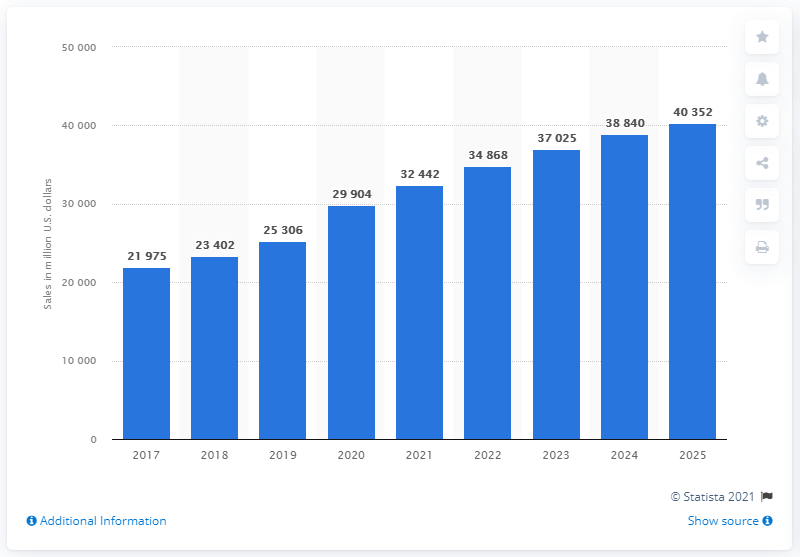Identify some key points in this picture. In the United States, retail e-commerce sales of physical goods totaled approximately 29,904 million U.S. dollars in 2021. According to projections, it is expected that retail e-commerce sales of physical goods will increase significantly in 2025. Specifically, the growth is projected to be 40,352. 